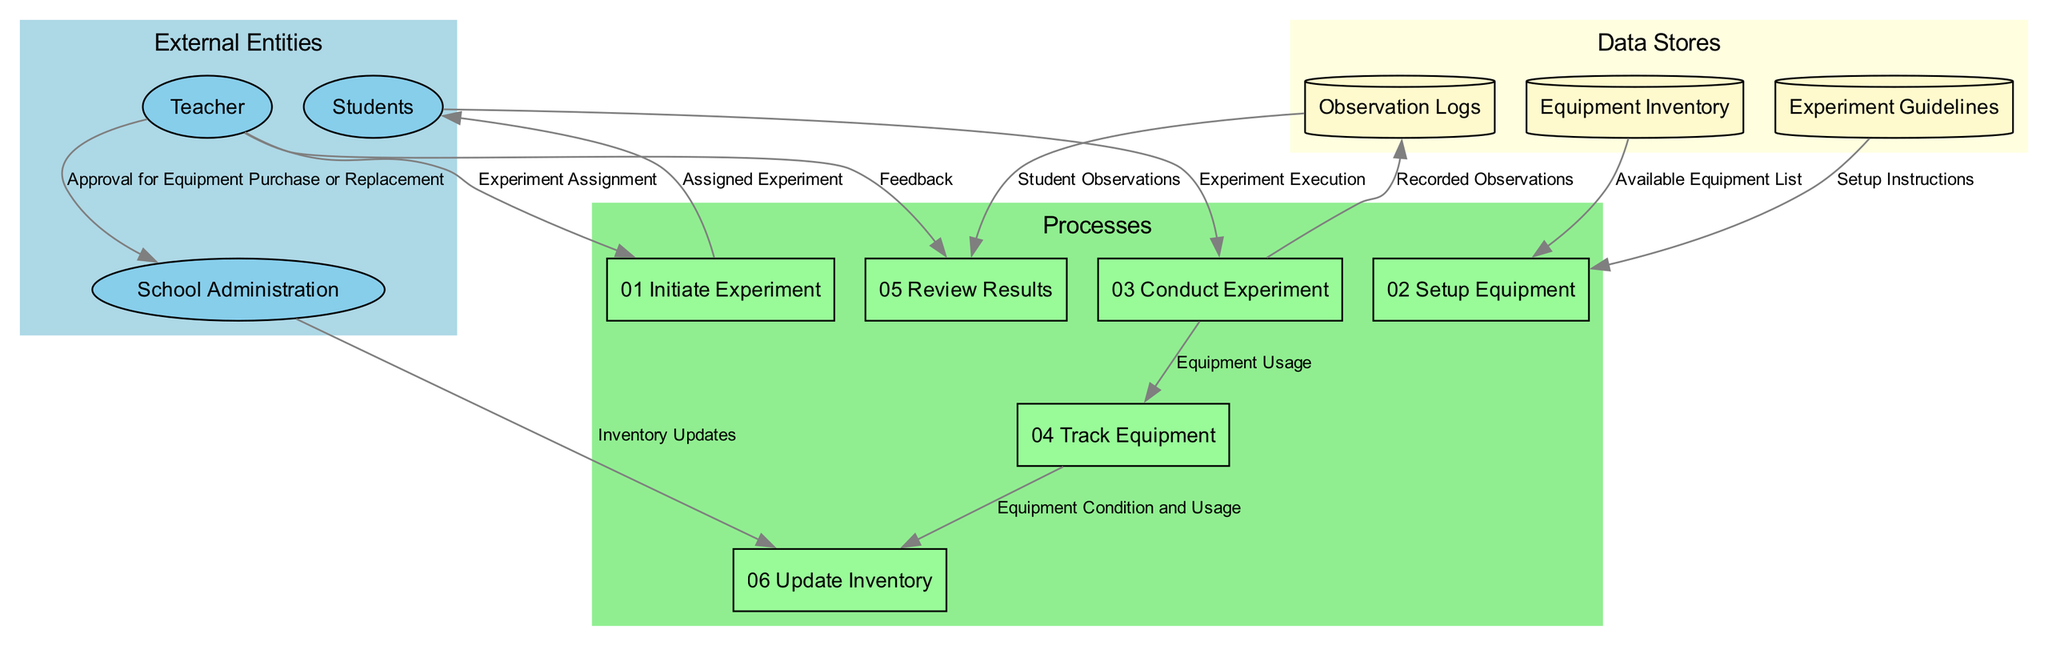What are the external entities involved in the process? The diagram shows three external entities: Teacher, Students, and School Administration. Each entity has a specific role in the laboratory experiment process.
Answer: Teacher, Students, School Administration How many processes are depicted in the diagram? The diagram contains six processes labeled from "01 Initiate Experiment" to "06 Update Inventory." Counting these processes gives a total of six.
Answer: 6 What is the first process in the sequence? The first process listed in the diagram is "01 Initiate Experiment," which indicates the starting point of the laboratory activity.
Answer: 01 Initiate Experiment What data flows from the Teacher to the Students? The data flow from the Teacher to the Students is labeled as "Assigned Experiment," which indicates what the Teacher communicates to the Students.
Answer: Assigned Experiment Which process logs the use and condition of the equipment? The process responsible for logging the use and condition of the equipment is labeled "04 Track Equipment." This indicates the step where equipment tracking occurs.
Answer: 04 Track Equipment What does the School Administration update based on tracked equipment usage? The School Administration updates the inventory records based on the tracked equipment usage and condition, indicating a critical link between equipment tracking and inventory management.
Answer: Inventory records What information does "Observation Logs" provide to the "Review Results" process? "Observation Logs" provide "Student Observations" to the "Review Results" process, which suggests that recorded data from Students is reviewed by the Teacher.
Answer: Student Observations How does the process of conducting the experiment link to equipment tracking? The process "03 Conduct Experiment" includes a data flow labeled "Equipment Usage" to "04 Track Equipment," signifying that conducting the experiment directly impacts the tracking of equipment.
Answer: Equipment Usage Which data store contains information on how to perform experiments? The data store that contains information on how to perform various experiments is labeled "Experiment Guidelines." This indicates that it serves as a reference for executing experiments.
Answer: Experiment Guidelines 